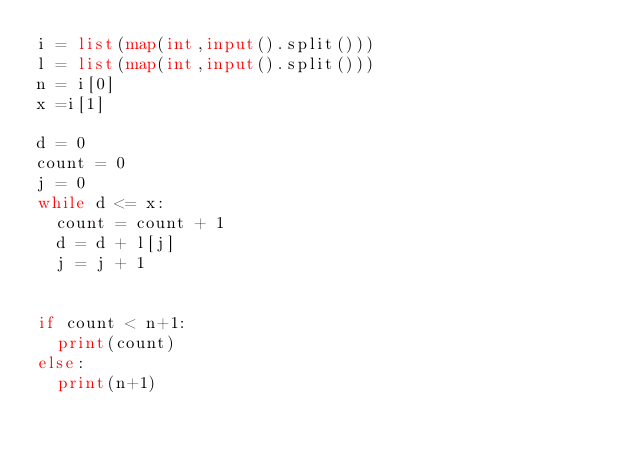<code> <loc_0><loc_0><loc_500><loc_500><_Python_>i = list(map(int,input().split()))
l = list(map(int,input().split()))
n = i[0]
x =i[1]

d = 0
count = 0
j = 0
while d <= x:
  count = count + 1
  d = d + l[j]
  j = j + 1
  

if count < n+1:
  print(count)
else:
  print(n+1)
</code> 